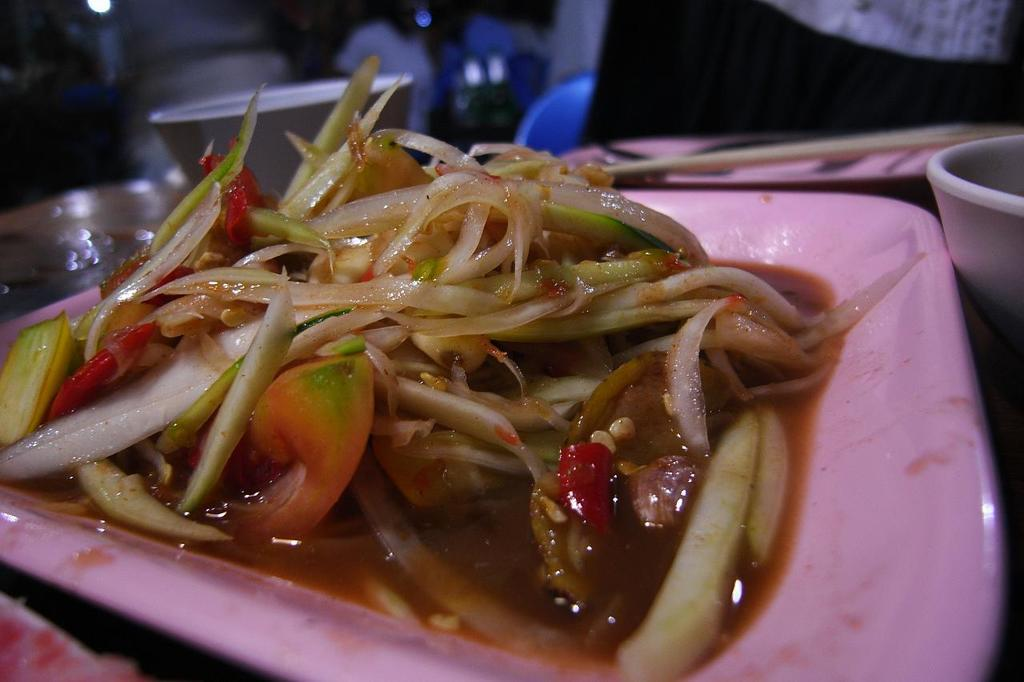What objects are located in the center of the image? There are plates, bowls, and food items in the center of the image. What type of items can be found in the center of the image? There are food items and objects in the center of the image. Can you describe the background of the image? The background of the image is blurred. What type of lace is used to decorate the plates in the image? There is no lace present on the plates in the image. How does the porter assist with the food items in the image? There is no porter present in the image; it only features plates, bowls, food items, and other objects. 